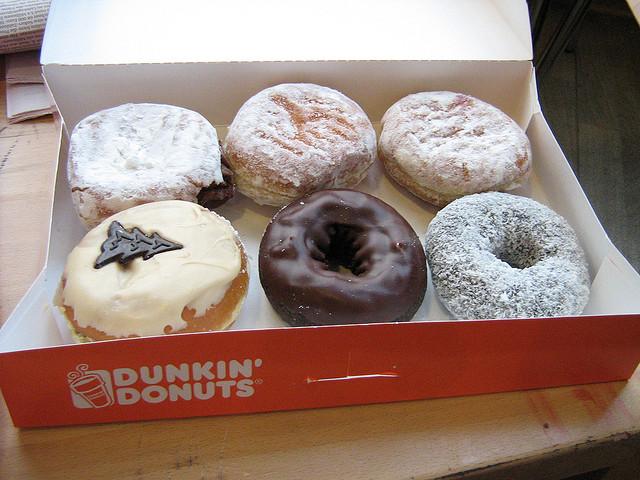What is the common name for this type of doughnut?
Short answer required. Jelly. Where are these doughnuts from?
Short answer required. Dunkin donuts. Are the doughnuts fried?
Short answer required. No. How many donuts are there?
Short answer required. 6. What does it say on the front of the box?
Write a very short answer. Dunkin donuts. What is the donut called on the right?
Be succinct. Powdered. What is the name of the bakery?
Quick response, please. Dunkin donuts. Is there coffee to go with the doughnuts?
Give a very brief answer. No. Is this a breakfast food?
Answer briefly. Yes. Are there mushrooms in the photo?
Quick response, please. No. What has the box been written?
Keep it brief. Dunkin donuts. How many pieces of chocolate are on the plate?
Keep it brief. 1. How large are the donuts?
Short answer required. Average. What color is the box?
Quick response, please. Orange. How many doughnuts can be seen?
Concise answer only. 6. 